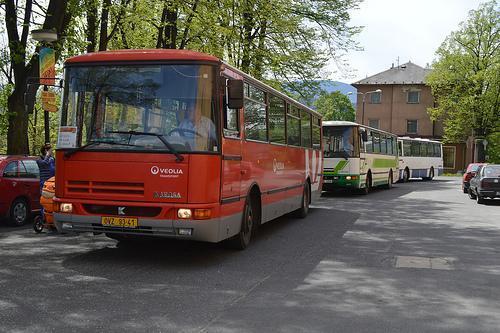How many people are in the picture?
Give a very brief answer. 1. How many buses are in the picture?
Give a very brief answer. 3. 